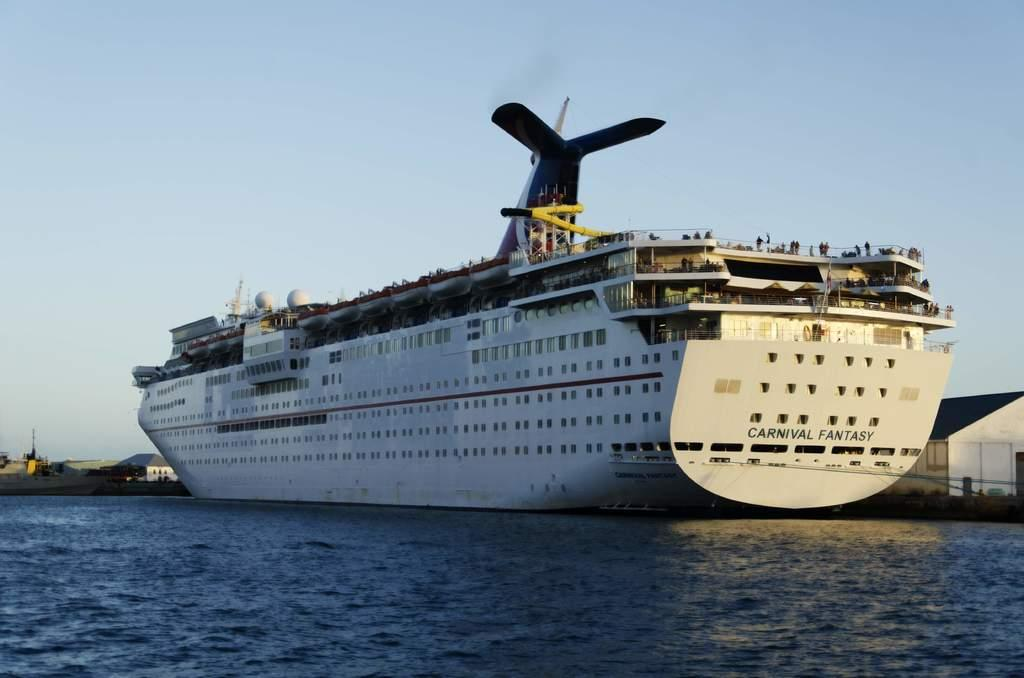<image>
Present a compact description of the photo's key features. The Carnival Fantasy large cruise ship docked at a port. 